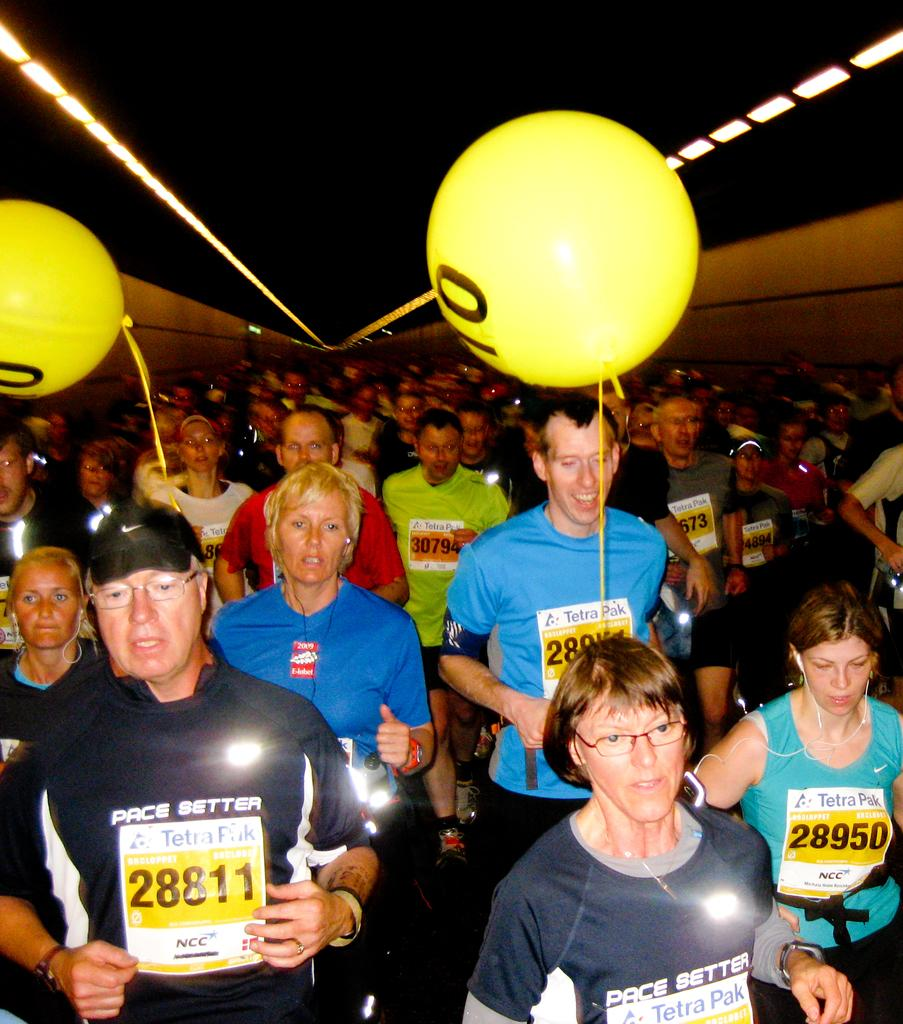How many people are in the image? There are persons standing in the image. What can be seen above the persons in the image? There are two yellow color balloons above them. What type of tomatoes are being used to make the soup in the image? There is no soup or tomatoes present in the image. What is the source of hope in the image? The image does not depict any source of hope, as it only features persons standing and yellow balloons. 